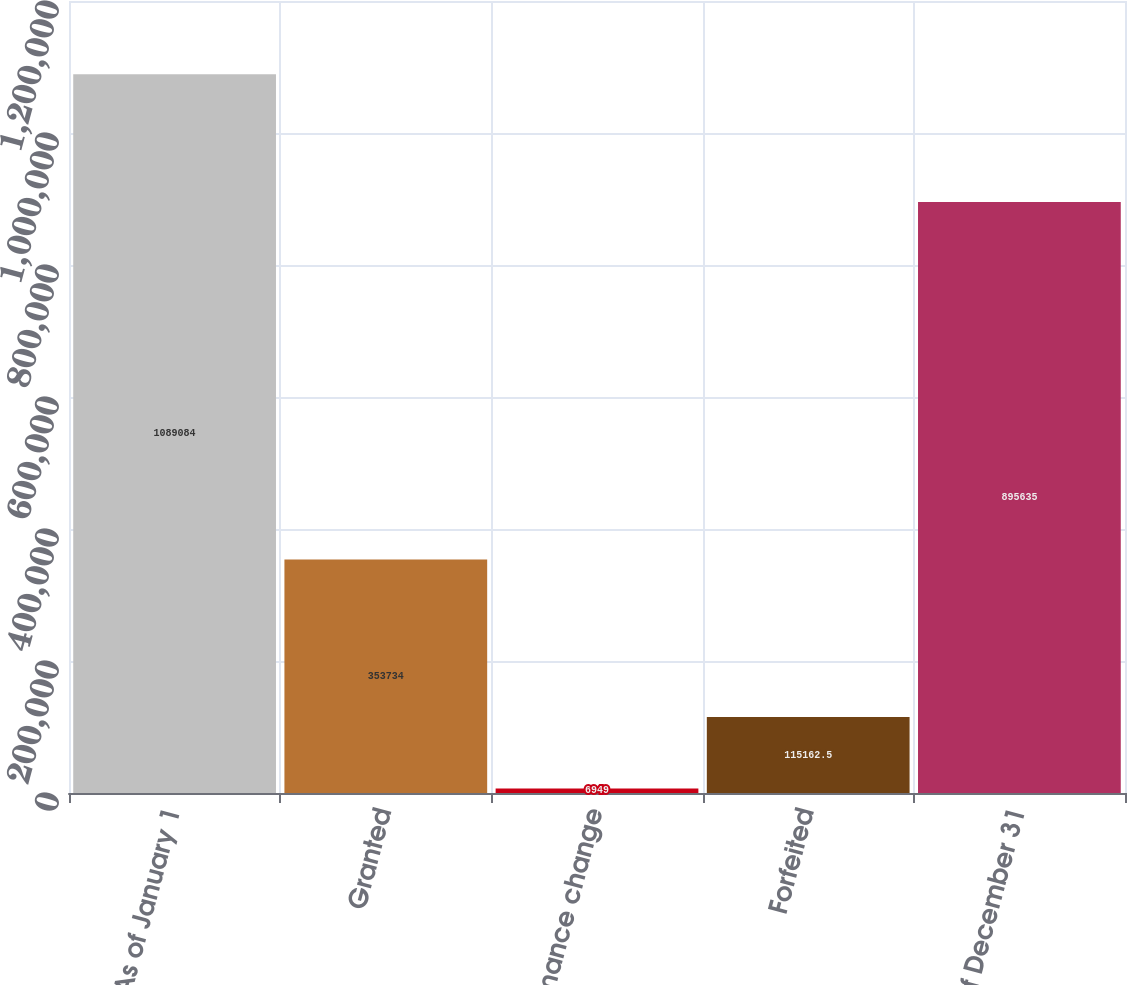Convert chart to OTSL. <chart><loc_0><loc_0><loc_500><loc_500><bar_chart><fcel>As of January 1<fcel>Granted<fcel>Performance change<fcel>Forfeited<fcel>As of December 31<nl><fcel>1.08908e+06<fcel>353734<fcel>6949<fcel>115162<fcel>895635<nl></chart> 